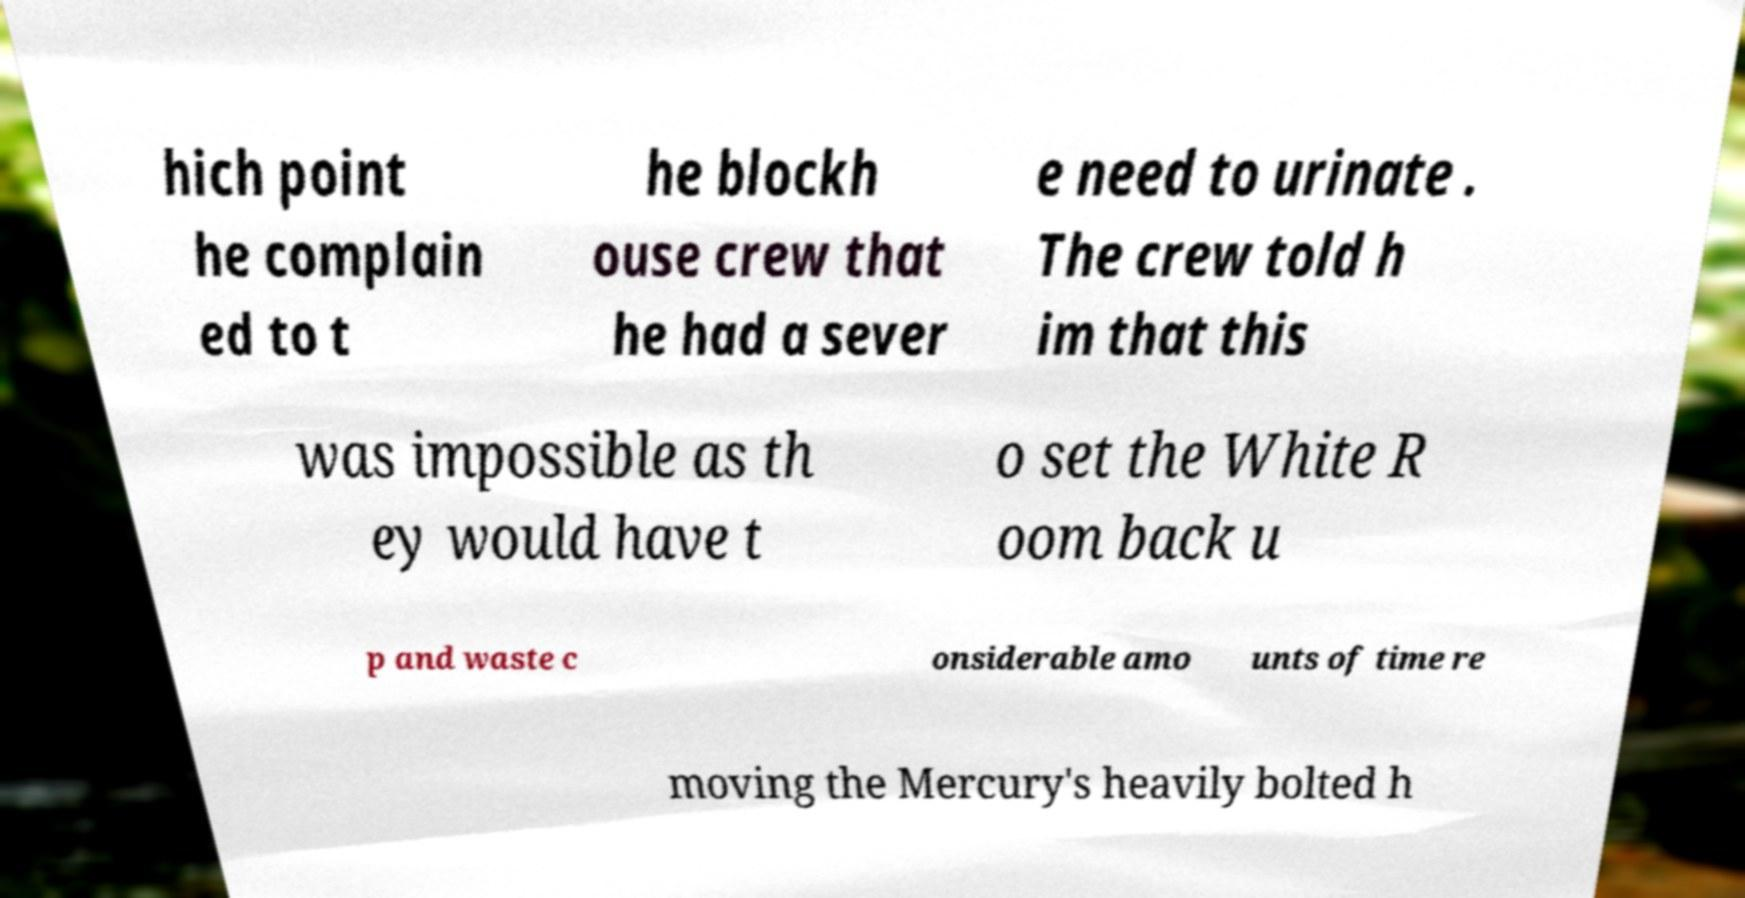Could you extract and type out the text from this image? hich point he complain ed to t he blockh ouse crew that he had a sever e need to urinate . The crew told h im that this was impossible as th ey would have t o set the White R oom back u p and waste c onsiderable amo unts of time re moving the Mercury's heavily bolted h 